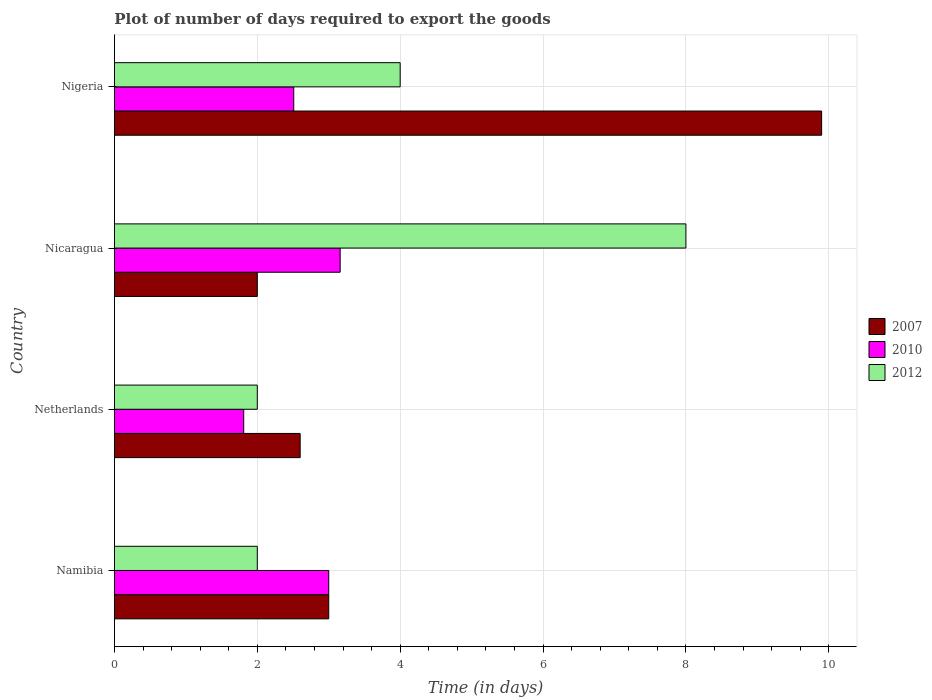How many groups of bars are there?
Your answer should be very brief. 4. Are the number of bars per tick equal to the number of legend labels?
Keep it short and to the point. Yes. How many bars are there on the 2nd tick from the bottom?
Provide a short and direct response. 3. What is the label of the 2nd group of bars from the top?
Make the answer very short. Nicaragua. In how many cases, is the number of bars for a given country not equal to the number of legend labels?
Offer a terse response. 0. Across all countries, what is the maximum time required to export goods in 2012?
Provide a succinct answer. 8. Across all countries, what is the minimum time required to export goods in 2010?
Make the answer very short. 1.81. In which country was the time required to export goods in 2007 maximum?
Your answer should be compact. Nigeria. In which country was the time required to export goods in 2012 minimum?
Provide a succinct answer. Namibia. What is the total time required to export goods in 2010 in the graph?
Your answer should be compact. 10.48. What is the difference between the time required to export goods in 2010 in Namibia and that in Nigeria?
Make the answer very short. 0.49. What is the difference between the time required to export goods in 2012 in Nicaragua and the time required to export goods in 2010 in Nigeria?
Ensure brevity in your answer.  5.49. What is the average time required to export goods in 2012 per country?
Provide a short and direct response. 4. What is the difference between the time required to export goods in 2010 and time required to export goods in 2007 in Nigeria?
Provide a short and direct response. -7.39. In how many countries, is the time required to export goods in 2007 greater than 8.8 days?
Offer a very short reply. 1. What is the ratio of the time required to export goods in 2010 in Namibia to that in Nicaragua?
Offer a very short reply. 0.95. Is the time required to export goods in 2012 in Netherlands less than that in Nigeria?
Make the answer very short. Yes. Is the difference between the time required to export goods in 2010 in Namibia and Netherlands greater than the difference between the time required to export goods in 2007 in Namibia and Netherlands?
Provide a short and direct response. Yes. What is the difference between the highest and the second highest time required to export goods in 2007?
Provide a succinct answer. 6.9. What is the difference between the highest and the lowest time required to export goods in 2010?
Keep it short and to the point. 1.35. In how many countries, is the time required to export goods in 2012 greater than the average time required to export goods in 2012 taken over all countries?
Ensure brevity in your answer.  1. What does the 2nd bar from the top in Netherlands represents?
Offer a terse response. 2010. Is it the case that in every country, the sum of the time required to export goods in 2007 and time required to export goods in 2010 is greater than the time required to export goods in 2012?
Make the answer very short. No. Are all the bars in the graph horizontal?
Provide a succinct answer. Yes. Are the values on the major ticks of X-axis written in scientific E-notation?
Provide a succinct answer. No. Does the graph contain any zero values?
Provide a succinct answer. No. Does the graph contain grids?
Keep it short and to the point. Yes. Where does the legend appear in the graph?
Give a very brief answer. Center right. How are the legend labels stacked?
Provide a succinct answer. Vertical. What is the title of the graph?
Ensure brevity in your answer.  Plot of number of days required to export the goods. Does "2009" appear as one of the legend labels in the graph?
Your answer should be compact. No. What is the label or title of the X-axis?
Provide a short and direct response. Time (in days). What is the Time (in days) of 2010 in Namibia?
Your answer should be very brief. 3. What is the Time (in days) of 2007 in Netherlands?
Offer a terse response. 2.6. What is the Time (in days) of 2010 in Netherlands?
Ensure brevity in your answer.  1.81. What is the Time (in days) of 2012 in Netherlands?
Make the answer very short. 2. What is the Time (in days) in 2010 in Nicaragua?
Provide a succinct answer. 3.16. What is the Time (in days) of 2012 in Nicaragua?
Your answer should be compact. 8. What is the Time (in days) in 2010 in Nigeria?
Provide a succinct answer. 2.51. Across all countries, what is the maximum Time (in days) of 2007?
Give a very brief answer. 9.9. Across all countries, what is the maximum Time (in days) of 2010?
Ensure brevity in your answer.  3.16. Across all countries, what is the minimum Time (in days) in 2010?
Keep it short and to the point. 1.81. What is the total Time (in days) of 2007 in the graph?
Your answer should be very brief. 17.5. What is the total Time (in days) in 2010 in the graph?
Provide a short and direct response. 10.48. What is the total Time (in days) in 2012 in the graph?
Keep it short and to the point. 16. What is the difference between the Time (in days) in 2007 in Namibia and that in Netherlands?
Keep it short and to the point. 0.4. What is the difference between the Time (in days) of 2010 in Namibia and that in Netherlands?
Offer a very short reply. 1.19. What is the difference between the Time (in days) of 2007 in Namibia and that in Nicaragua?
Offer a very short reply. 1. What is the difference between the Time (in days) in 2010 in Namibia and that in Nicaragua?
Ensure brevity in your answer.  -0.16. What is the difference between the Time (in days) in 2012 in Namibia and that in Nicaragua?
Make the answer very short. -6. What is the difference between the Time (in days) in 2010 in Namibia and that in Nigeria?
Give a very brief answer. 0.49. What is the difference between the Time (in days) of 2012 in Namibia and that in Nigeria?
Make the answer very short. -2. What is the difference between the Time (in days) in 2007 in Netherlands and that in Nicaragua?
Offer a very short reply. 0.6. What is the difference between the Time (in days) in 2010 in Netherlands and that in Nicaragua?
Offer a terse response. -1.35. What is the difference between the Time (in days) in 2007 in Netherlands and that in Nigeria?
Provide a short and direct response. -7.3. What is the difference between the Time (in days) of 2012 in Netherlands and that in Nigeria?
Keep it short and to the point. -2. What is the difference between the Time (in days) in 2010 in Nicaragua and that in Nigeria?
Provide a succinct answer. 0.65. What is the difference between the Time (in days) of 2007 in Namibia and the Time (in days) of 2010 in Netherlands?
Offer a terse response. 1.19. What is the difference between the Time (in days) in 2007 in Namibia and the Time (in days) in 2012 in Netherlands?
Ensure brevity in your answer.  1. What is the difference between the Time (in days) of 2007 in Namibia and the Time (in days) of 2010 in Nicaragua?
Keep it short and to the point. -0.16. What is the difference between the Time (in days) of 2010 in Namibia and the Time (in days) of 2012 in Nicaragua?
Your response must be concise. -5. What is the difference between the Time (in days) of 2007 in Namibia and the Time (in days) of 2010 in Nigeria?
Provide a succinct answer. 0.49. What is the difference between the Time (in days) of 2007 in Namibia and the Time (in days) of 2012 in Nigeria?
Offer a terse response. -1. What is the difference between the Time (in days) of 2007 in Netherlands and the Time (in days) of 2010 in Nicaragua?
Offer a very short reply. -0.56. What is the difference between the Time (in days) in 2010 in Netherlands and the Time (in days) in 2012 in Nicaragua?
Offer a terse response. -6.19. What is the difference between the Time (in days) of 2007 in Netherlands and the Time (in days) of 2010 in Nigeria?
Your response must be concise. 0.09. What is the difference between the Time (in days) in 2007 in Netherlands and the Time (in days) in 2012 in Nigeria?
Your response must be concise. -1.4. What is the difference between the Time (in days) in 2010 in Netherlands and the Time (in days) in 2012 in Nigeria?
Provide a succinct answer. -2.19. What is the difference between the Time (in days) of 2007 in Nicaragua and the Time (in days) of 2010 in Nigeria?
Give a very brief answer. -0.51. What is the difference between the Time (in days) of 2010 in Nicaragua and the Time (in days) of 2012 in Nigeria?
Offer a very short reply. -0.84. What is the average Time (in days) in 2007 per country?
Your answer should be very brief. 4.38. What is the average Time (in days) in 2010 per country?
Offer a terse response. 2.62. What is the average Time (in days) in 2012 per country?
Provide a succinct answer. 4. What is the difference between the Time (in days) of 2007 and Time (in days) of 2012 in Namibia?
Provide a short and direct response. 1. What is the difference between the Time (in days) of 2010 and Time (in days) of 2012 in Namibia?
Ensure brevity in your answer.  1. What is the difference between the Time (in days) in 2007 and Time (in days) in 2010 in Netherlands?
Your response must be concise. 0.79. What is the difference between the Time (in days) of 2007 and Time (in days) of 2012 in Netherlands?
Your answer should be very brief. 0.6. What is the difference between the Time (in days) of 2010 and Time (in days) of 2012 in Netherlands?
Make the answer very short. -0.19. What is the difference between the Time (in days) of 2007 and Time (in days) of 2010 in Nicaragua?
Your answer should be compact. -1.16. What is the difference between the Time (in days) of 2007 and Time (in days) of 2012 in Nicaragua?
Your response must be concise. -6. What is the difference between the Time (in days) in 2010 and Time (in days) in 2012 in Nicaragua?
Ensure brevity in your answer.  -4.84. What is the difference between the Time (in days) in 2007 and Time (in days) in 2010 in Nigeria?
Your answer should be very brief. 7.39. What is the difference between the Time (in days) of 2010 and Time (in days) of 2012 in Nigeria?
Offer a very short reply. -1.49. What is the ratio of the Time (in days) in 2007 in Namibia to that in Netherlands?
Your answer should be compact. 1.15. What is the ratio of the Time (in days) of 2010 in Namibia to that in Netherlands?
Offer a terse response. 1.66. What is the ratio of the Time (in days) in 2010 in Namibia to that in Nicaragua?
Give a very brief answer. 0.95. What is the ratio of the Time (in days) of 2007 in Namibia to that in Nigeria?
Offer a very short reply. 0.3. What is the ratio of the Time (in days) of 2010 in Namibia to that in Nigeria?
Your answer should be compact. 1.2. What is the ratio of the Time (in days) in 2010 in Netherlands to that in Nicaragua?
Your answer should be compact. 0.57. What is the ratio of the Time (in days) in 2012 in Netherlands to that in Nicaragua?
Offer a very short reply. 0.25. What is the ratio of the Time (in days) in 2007 in Netherlands to that in Nigeria?
Offer a terse response. 0.26. What is the ratio of the Time (in days) of 2010 in Netherlands to that in Nigeria?
Provide a short and direct response. 0.72. What is the ratio of the Time (in days) of 2007 in Nicaragua to that in Nigeria?
Your answer should be compact. 0.2. What is the ratio of the Time (in days) of 2010 in Nicaragua to that in Nigeria?
Offer a very short reply. 1.26. What is the ratio of the Time (in days) of 2012 in Nicaragua to that in Nigeria?
Offer a terse response. 2. What is the difference between the highest and the second highest Time (in days) in 2010?
Give a very brief answer. 0.16. What is the difference between the highest and the lowest Time (in days) in 2007?
Give a very brief answer. 7.9. What is the difference between the highest and the lowest Time (in days) in 2010?
Keep it short and to the point. 1.35. 